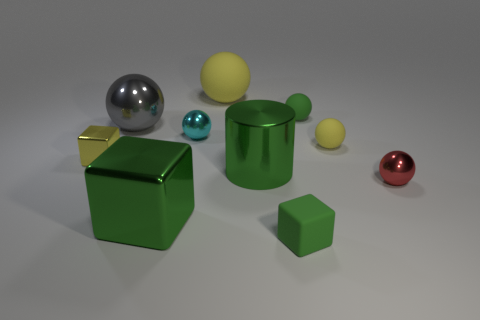Subtract all yellow rubber balls. How many balls are left? 4 Subtract all cylinders. How many objects are left? 9 Subtract all cyan balls. How many balls are left? 5 Subtract 2 balls. How many balls are left? 4 Subtract all brown balls. Subtract all yellow cylinders. How many balls are left? 6 Subtract all purple cylinders. How many red spheres are left? 1 Subtract all tiny rubber cylinders. Subtract all small yellow cubes. How many objects are left? 9 Add 9 tiny yellow rubber objects. How many tiny yellow rubber objects are left? 10 Add 1 big metal balls. How many big metal balls exist? 2 Subtract 0 brown cubes. How many objects are left? 10 